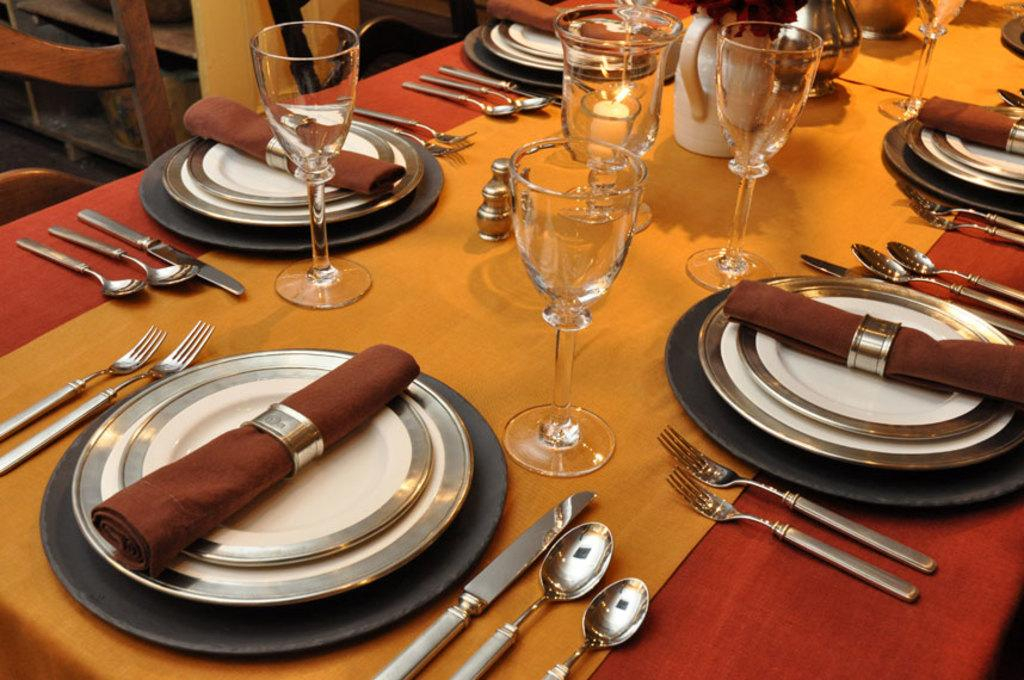What types of utensils are on the table in the image? There are spoons, forks, and knives on the table in the image. What type of dishware is on the table? There are plates on the table. What other items can be seen on the table? There are clothes, glasses, a flower vase, and a pot on the table. Are there any chairs visible in the image? Yes, there are chairs in the left top corner of the image. How many rabbits are sitting on the table in the image? There are no rabbits present on the table in the image. What type of bead is used to decorate the glasses in the image? There is no mention of beads or decorations on the glasses in the image. 